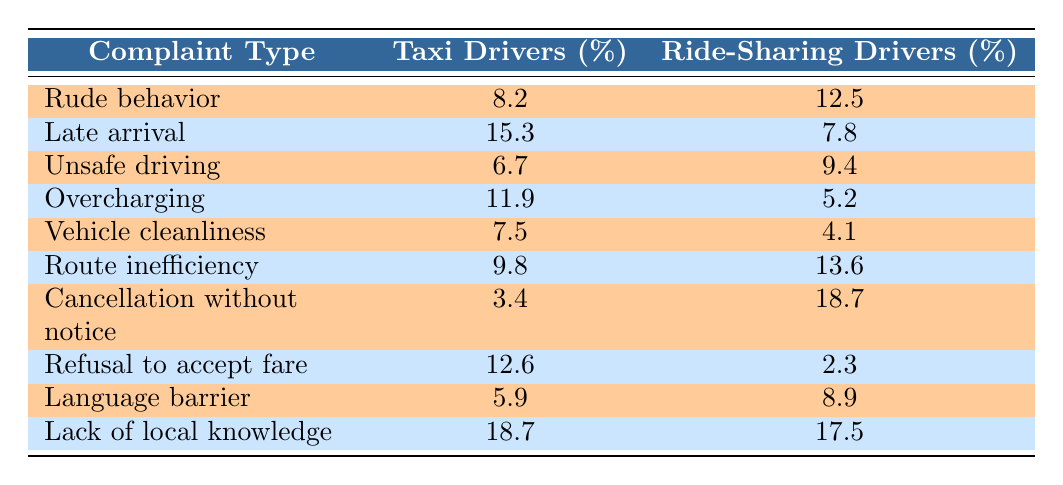What is the percentage of complaints about rude behavior for taxi drivers? The table shows that the percentage of complaints regarding rude behavior for taxi drivers is listed directly under the "Taxi Drivers (%)" column for that complaint type. It is 8.2%.
Answer: 8.2% Which type of complaint has the highest percentage against ride-sharing drivers? Looking through the "Ride-Sharing Drivers (%)" column, the complaint type with the highest value can be found by scanning each row. The highest percentage is 18.7% for "Cancellation without notice".
Answer: 18.7% What is the difference in the percentage of complaints about late arrival between taxi and ride-sharing drivers? To find the difference, subtract the percentage for ride-sharing drivers (7.8%) from the percentage for taxi drivers (15.3%). The calculation is 15.3% - 7.8% = 7.5%.
Answer: 7.5% Are taxi drivers more commonly complained about for refusing to accept fares than ride-sharing drivers? By examining the respective percentages in the table, taxi drivers have a refusal to accept fare complaint rate of 12.6% while ride-sharing drivers have a rate of 2.3%. Since 12.6% is greater than 2.3%, the statement is true.
Answer: Yes What is the average percentage of complaints regarding vehicle cleanliness and unsafe driving for taxi drivers? The values for taxi drivers are 7.5% for vehicle cleanliness and 6.7% for unsafe driving. To find the average, add the two percentages: 7.5% + 6.7% = 14.2%, then divide by 2, which gives 14.2% / 2 = 7.1%.
Answer: 7.1% Which complaint type has the lowest percentage for ride-sharing drivers? By scanning the "Ride-Sharing Drivers (%)" column to find the smallest value, we see that "Overcharging" has the lowest percentage at 5.2%.
Answer: 5.2% Is it true that a higher percentage of complaints about cancellation without notice is filed against ride-sharing drivers compared to taxi drivers? Reviewing the percentages shows that ride-sharing drivers have 18.7% while taxi drivers have 3.4%. Since 18.7% is significantly higher, the statement is true.
Answer: Yes What two complaint types have a combined percentage of over 30% for taxi drivers? To find two complaint types that exceed a combined percentage of 30%, we look at the values for taxi drivers: "Late arrival" (15.3%) and "Refusal to accept fare" (12.6%) combine to 27.9%, which is less than 30%. However, "Late arrival" (15.3%) and "Lack of local knowledge" (18.7%) combine to 34%, surpassing 30%.
Answer: Yes What percentage of complaints regarding unsafe driving is file against ride-sharing drivers? The table indicates that the percentage of complaints regarding unsafe driving for ride-sharing drivers is 9.4% listed in the corresponding cell under that complaint type.
Answer: 9.4% How does the complaint percentage for vehicle cleanliness compare between the two driver types? Looking at the percentages, taxi drivers have a complaint rate of 7.5% while ride-sharing drivers have 4.1%. The taxi drivers have a higher complaint percentage by 3.4%.
Answer: Taxi drivers have 3.4% higher complaints 